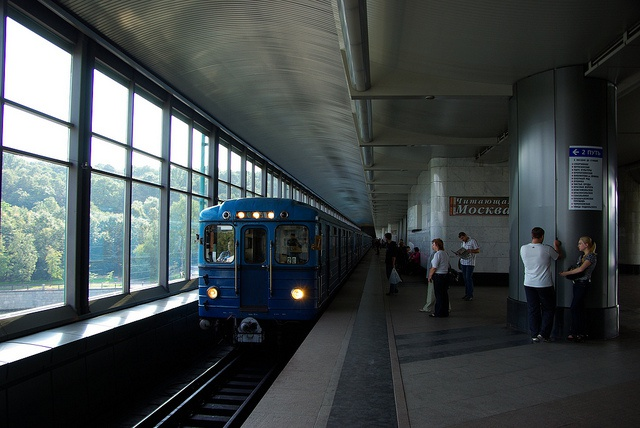Describe the objects in this image and their specific colors. I can see train in black, navy, and blue tones, people in black, darkgray, and gray tones, people in black, gray, and maroon tones, people in black, gray, and darkblue tones, and people in black, gray, and purple tones in this image. 